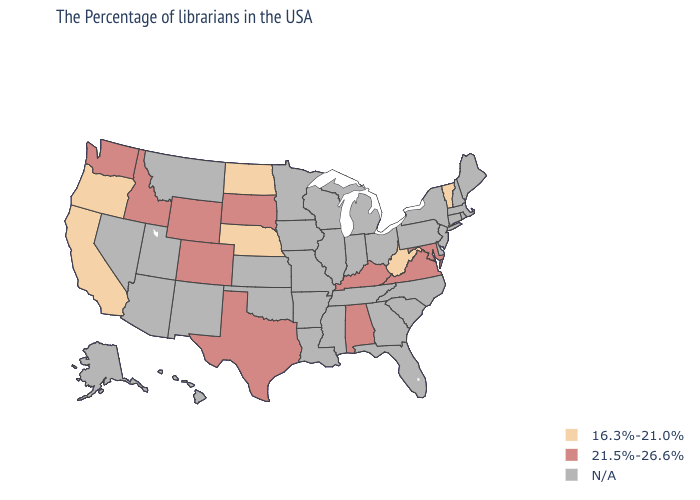How many symbols are there in the legend?
Write a very short answer. 3. Which states hav the highest value in the South?
Answer briefly. Maryland, Virginia, Kentucky, Alabama, Texas. Among the states that border Arkansas , which have the highest value?
Be succinct. Texas. Name the states that have a value in the range 16.3%-21.0%?
Concise answer only. Vermont, West Virginia, Nebraska, North Dakota, California, Oregon. How many symbols are there in the legend?
Short answer required. 3. Name the states that have a value in the range N/A?
Answer briefly. Maine, Massachusetts, Rhode Island, New Hampshire, Connecticut, New York, New Jersey, Delaware, Pennsylvania, North Carolina, South Carolina, Ohio, Florida, Georgia, Michigan, Indiana, Tennessee, Wisconsin, Illinois, Mississippi, Louisiana, Missouri, Arkansas, Minnesota, Iowa, Kansas, Oklahoma, New Mexico, Utah, Montana, Arizona, Nevada, Alaska, Hawaii. What is the value of Missouri?
Be succinct. N/A. What is the value of Illinois?
Concise answer only. N/A. Among the states that border Nevada , which have the lowest value?
Write a very short answer. California, Oregon. Name the states that have a value in the range N/A?
Be succinct. Maine, Massachusetts, Rhode Island, New Hampshire, Connecticut, New York, New Jersey, Delaware, Pennsylvania, North Carolina, South Carolina, Ohio, Florida, Georgia, Michigan, Indiana, Tennessee, Wisconsin, Illinois, Mississippi, Louisiana, Missouri, Arkansas, Minnesota, Iowa, Kansas, Oklahoma, New Mexico, Utah, Montana, Arizona, Nevada, Alaska, Hawaii. Name the states that have a value in the range N/A?
Give a very brief answer. Maine, Massachusetts, Rhode Island, New Hampshire, Connecticut, New York, New Jersey, Delaware, Pennsylvania, North Carolina, South Carolina, Ohio, Florida, Georgia, Michigan, Indiana, Tennessee, Wisconsin, Illinois, Mississippi, Louisiana, Missouri, Arkansas, Minnesota, Iowa, Kansas, Oklahoma, New Mexico, Utah, Montana, Arizona, Nevada, Alaska, Hawaii. Name the states that have a value in the range N/A?
Quick response, please. Maine, Massachusetts, Rhode Island, New Hampshire, Connecticut, New York, New Jersey, Delaware, Pennsylvania, North Carolina, South Carolina, Ohio, Florida, Georgia, Michigan, Indiana, Tennessee, Wisconsin, Illinois, Mississippi, Louisiana, Missouri, Arkansas, Minnesota, Iowa, Kansas, Oklahoma, New Mexico, Utah, Montana, Arizona, Nevada, Alaska, Hawaii. What is the lowest value in the USA?
Short answer required. 16.3%-21.0%. 